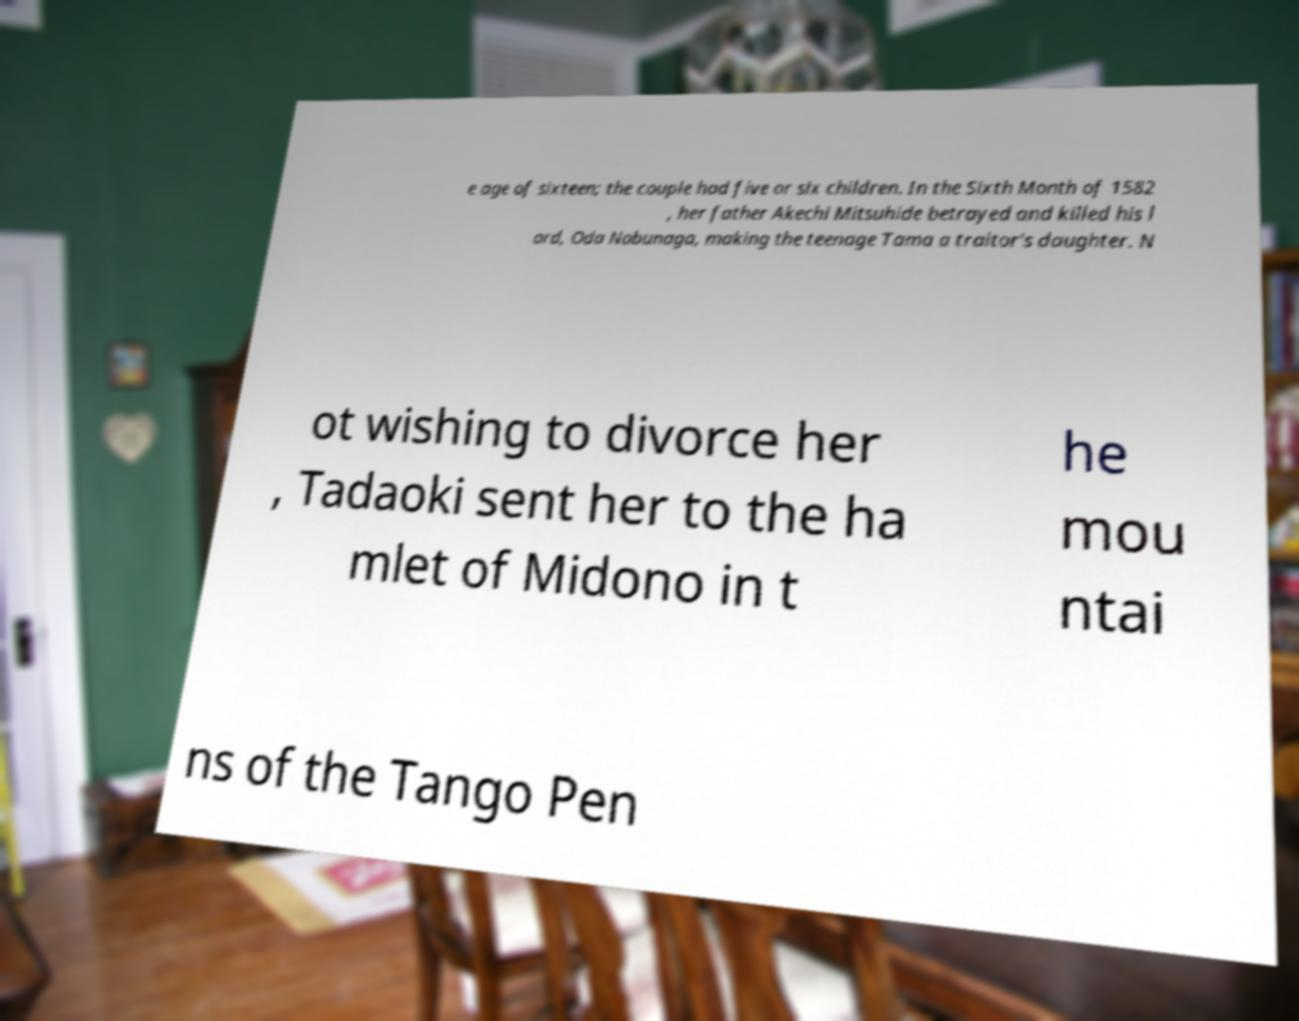For documentation purposes, I need the text within this image transcribed. Could you provide that? e age of sixteen; the couple had five or six children. In the Sixth Month of 1582 , her father Akechi Mitsuhide betrayed and killed his l ord, Oda Nobunaga, making the teenage Tama a traitor's daughter. N ot wishing to divorce her , Tadaoki sent her to the ha mlet of Midono in t he mou ntai ns of the Tango Pen 